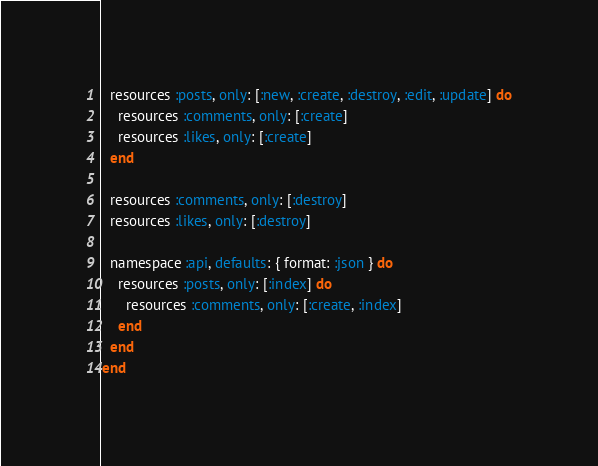Convert code to text. <code><loc_0><loc_0><loc_500><loc_500><_Ruby_>  resources :posts, only: [:new, :create, :destroy, :edit, :update] do
    resources :comments, only: [:create]
    resources :likes, only: [:create]
  end

  resources :comments, only: [:destroy]
  resources :likes, only: [:destroy]

  namespace :api, defaults: { format: :json } do
    resources :posts, only: [:index] do
      resources :comments, only: [:create, :index]
    end
  end
end



</code> 